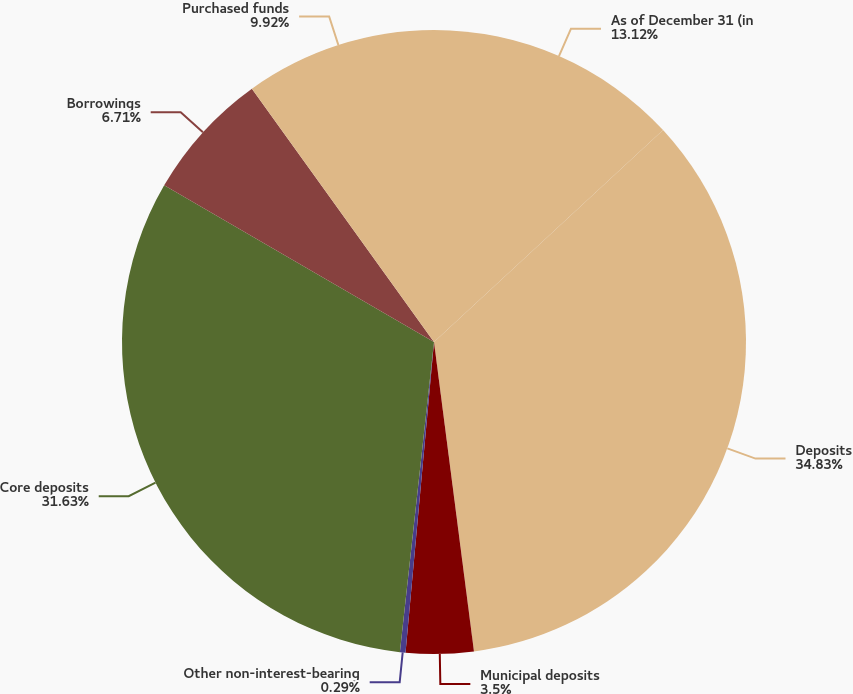Convert chart to OTSL. <chart><loc_0><loc_0><loc_500><loc_500><pie_chart><fcel>As of December 31 (in<fcel>Deposits<fcel>Municipal deposits<fcel>Other non-interest-bearing<fcel>Core deposits<fcel>Borrowings<fcel>Purchased funds<nl><fcel>13.12%<fcel>34.84%<fcel>3.5%<fcel>0.29%<fcel>31.63%<fcel>6.71%<fcel>9.92%<nl></chart> 